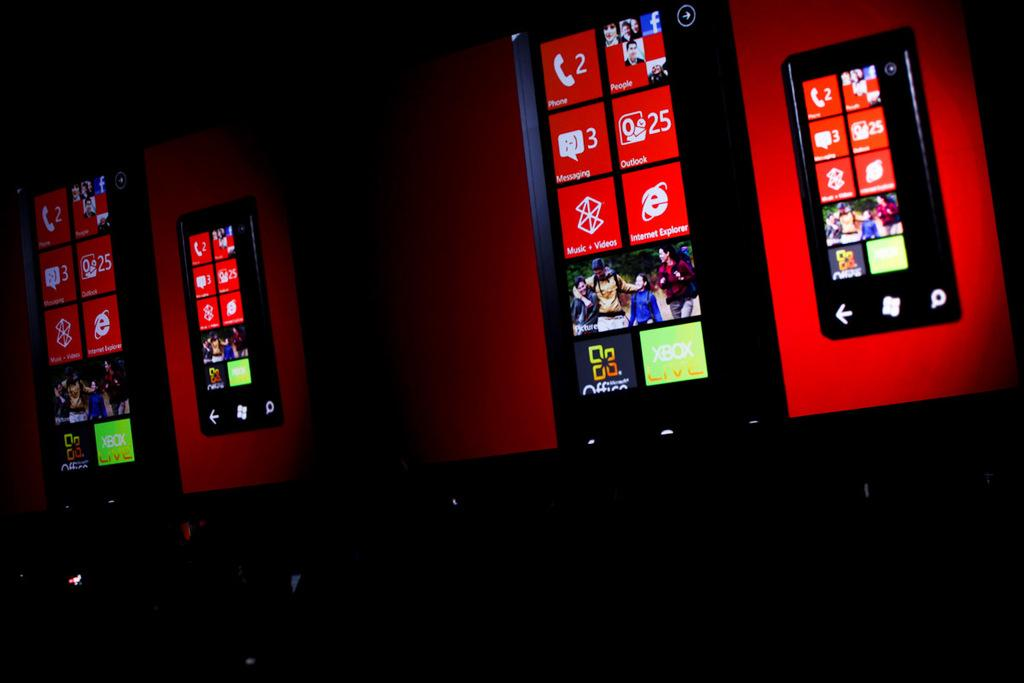<image>
Give a short and clear explanation of the subsequent image. A display of huge mobile phone screens show various windows tiles such as phone and explorer. 